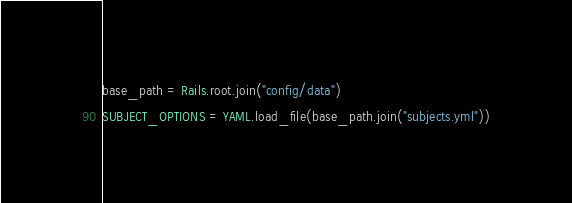<code> <loc_0><loc_0><loc_500><loc_500><_Ruby_>base_path = Rails.root.join("config/data")

SUBJECT_OPTIONS = YAML.load_file(base_path.join("subjects.yml"))
</code> 